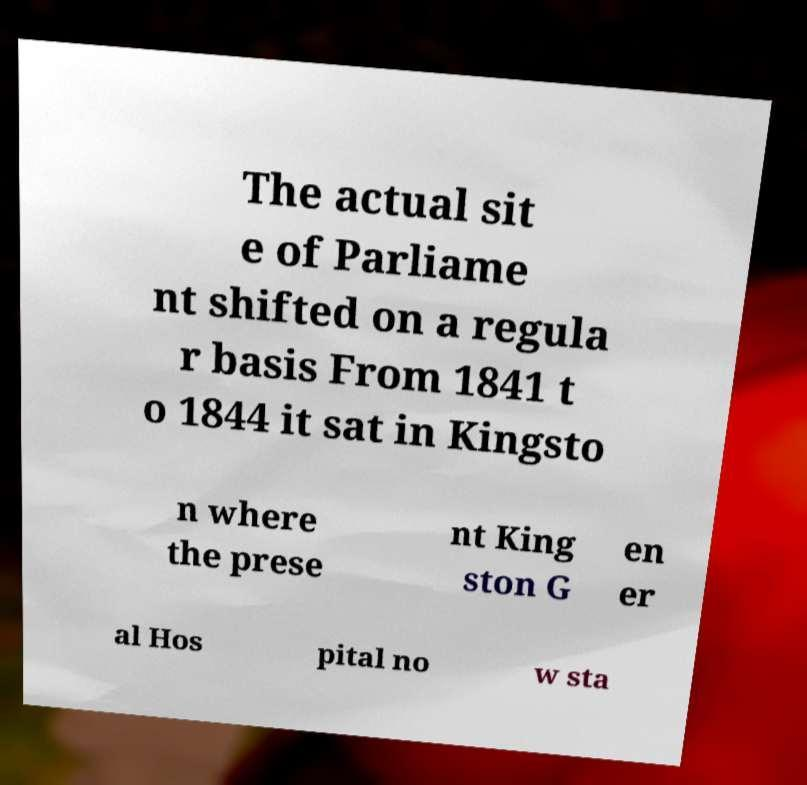Could you extract and type out the text from this image? The actual sit e of Parliame nt shifted on a regula r basis From 1841 t o 1844 it sat in Kingsto n where the prese nt King ston G en er al Hos pital no w sta 